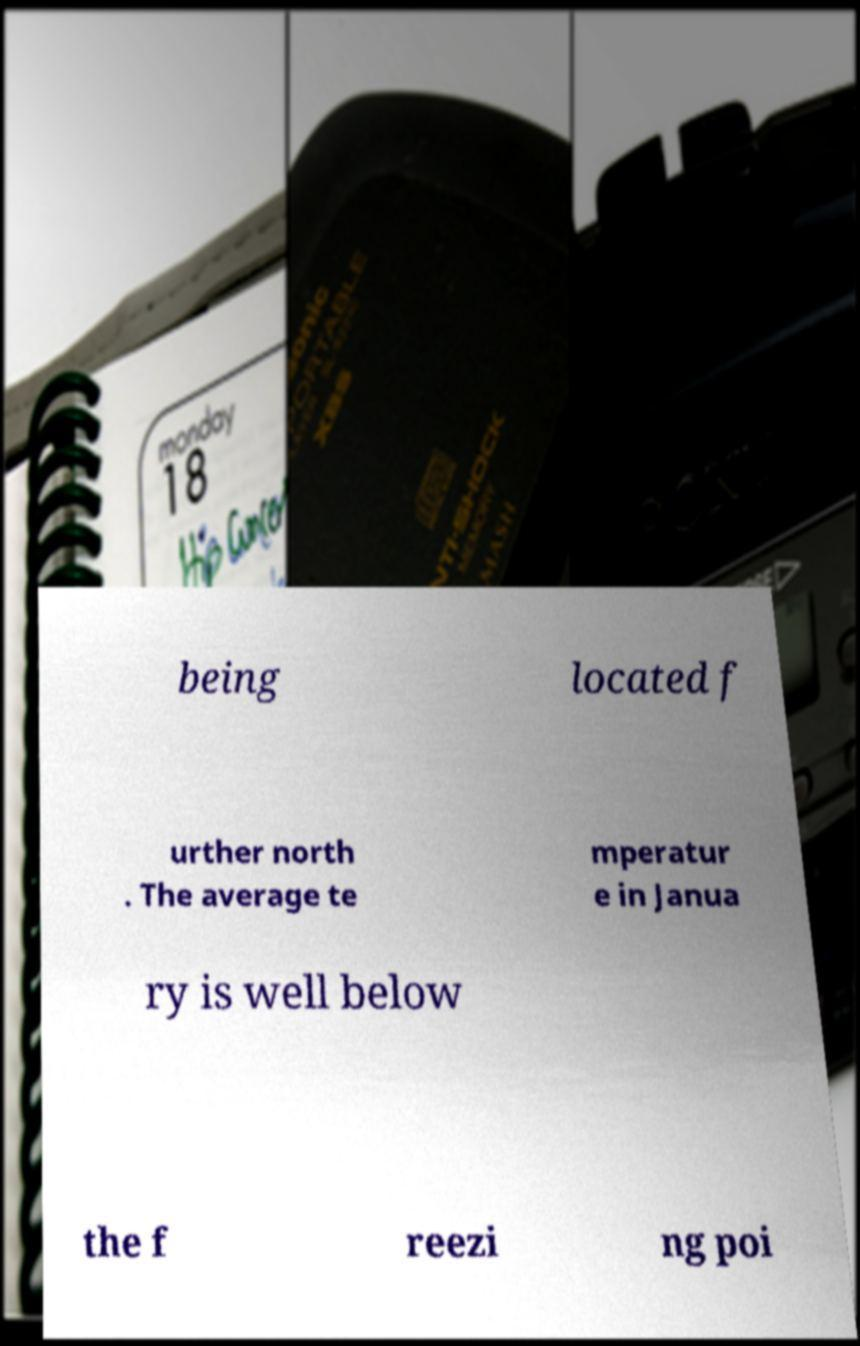Could you extract and type out the text from this image? being located f urther north . The average te mperatur e in Janua ry is well below the f reezi ng poi 